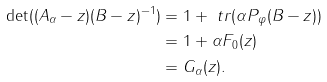Convert formula to latex. <formula><loc_0><loc_0><loc_500><loc_500>\det ( ( A _ { \alpha } - z ) ( B - z ) ^ { - 1 } ) & = 1 + \ t r ( \alpha P _ { \varphi } ( B - z ) ) \\ & = 1 + \alpha F _ { 0 } ( z ) \\ & = G _ { \alpha } ( z ) .</formula> 